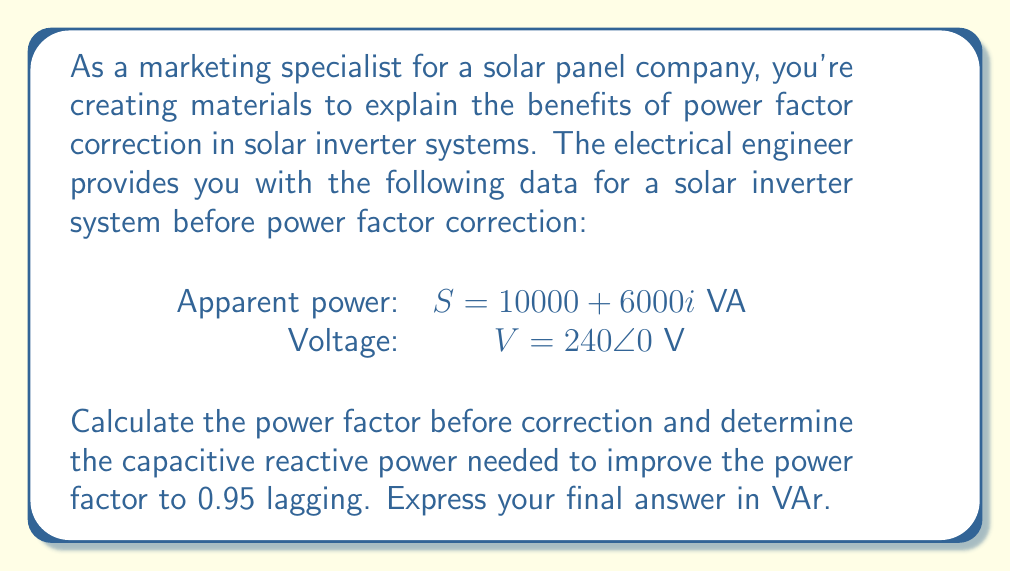Can you answer this question? Let's approach this step-by-step:

1) First, we need to calculate the current power factor:
   
   $S = P + jQ = 10000 + 6000i$ VA
   
   Power factor (PF) = $\cos \theta = \frac{P}{|S|}$

   $|S| = \sqrt{10000^2 + 6000^2} = 11661.90$ VA

   PF = $\frac{10000}{11661.90} = 0.8574$ (lagging)

2) To improve the power factor to 0.95 lagging, we need to reduce the reactive power. Let's calculate the new reactive power $Q_{new}$ for PF = 0.95:

   $\cos \theta_{new} = 0.95$
   $\theta_{new} = \arccos(0.95) = 18.19°$
   
   $\tan \theta_{new} = \frac{Q_{new}}{P} = 0.3287$
   
   $Q_{new} = P \tan \theta_{new} = 10000 \times 0.3287 = 3287$ VAr

3) The capacitive reactive power needed $Q_c$ is the difference between the original and new reactive power:

   $Q_c = Q - Q_{new} = 6000 - 3287 = 2713$ VAr

This capacitive reactive power is what's needed to improve the power factor to 0.95 lagging.
Answer: 2713 VAr 